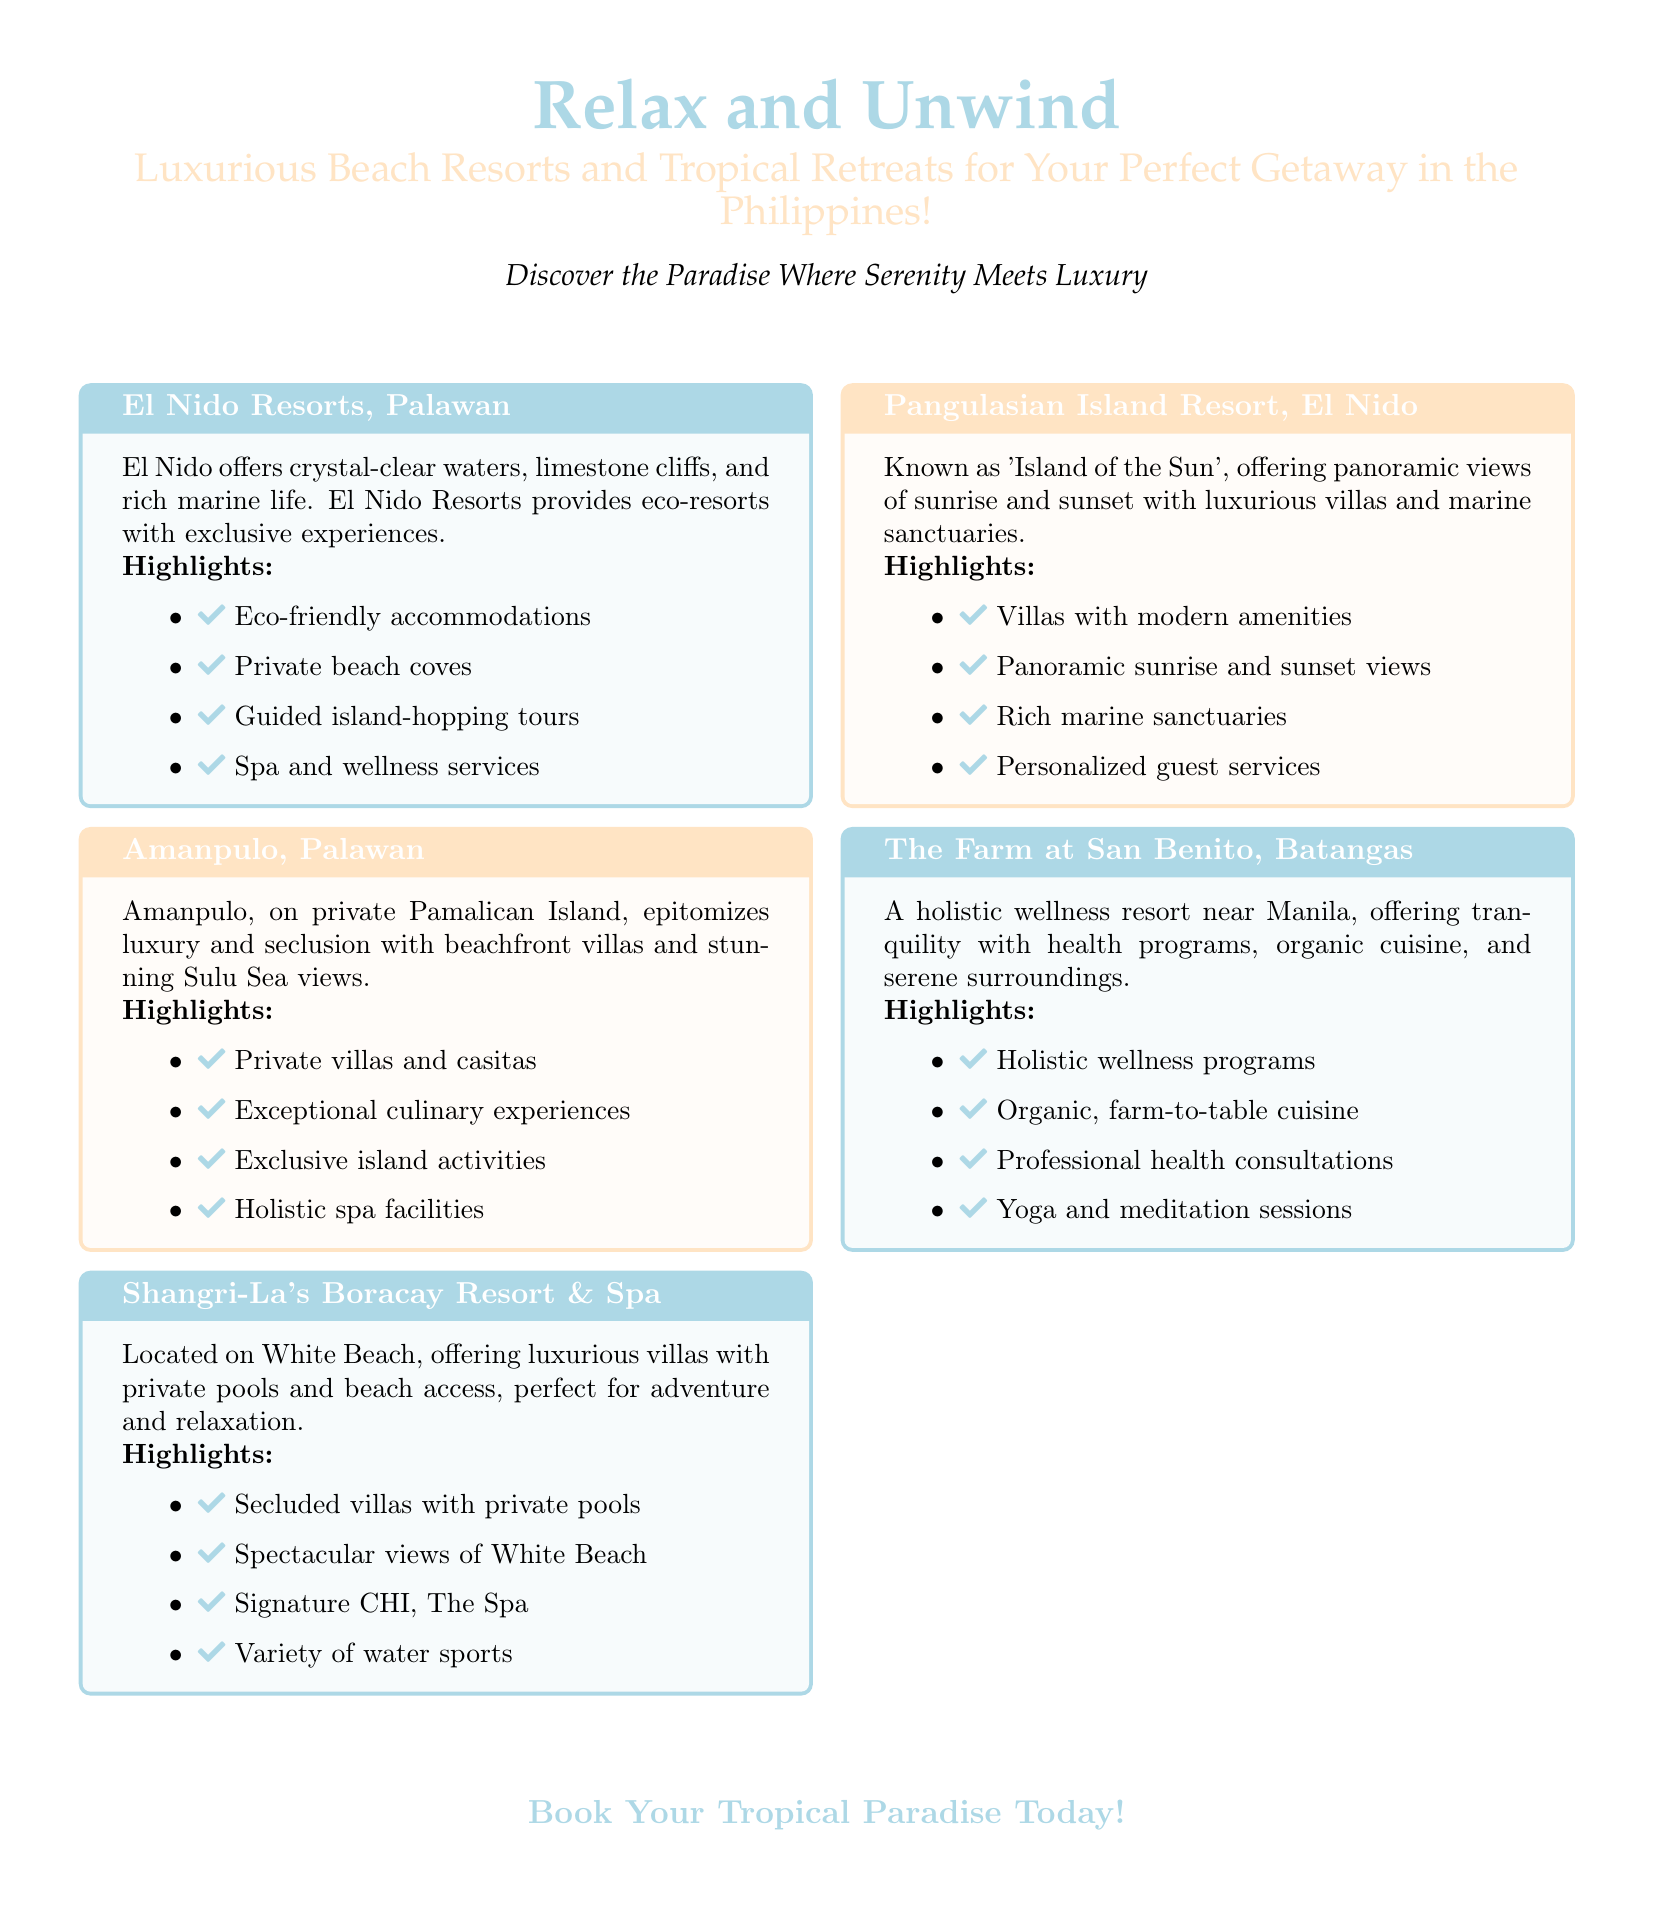What is the first resort mentioned? The first resort listed in the document is El Nido Resorts, Palawan.
Answer: El Nido Resorts, Palawan How many highlights does Amanpulo have? The document lists four highlights for Amanpulo.
Answer: 4 What type of cuisine does The Farm at San Benito offer? The Farm at San Benito is known for organic, farm-to-table cuisine.
Answer: Organic, farm-to-table What is the special feature of Shangri-La's Boracay Resort & Spa? Shangri-La's Boracay Resort & Spa features secluded villas with private pools.
Answer: Secluded villas with private pools Which resort is referred to as the 'Island of the Sun'? Pangulasian Island Resort is also known as the 'Island of the Sun'.
Answer: Pangulasian Island Resort What activity is primarily offered at El Nido Resorts? El Nido Resorts primarily offers guided island-hopping tours.
Answer: Guided island-hopping tours What wellness features does The Farm at San Benito include? The Farm at San Benito includes holistic wellness programs and yoga sessions.
Answer: Holistic wellness programs and yoga sessions Where is Amanpulo located? Amanpulo is situated on private Pamalican Island.
Answer: Private Pamalican Island 